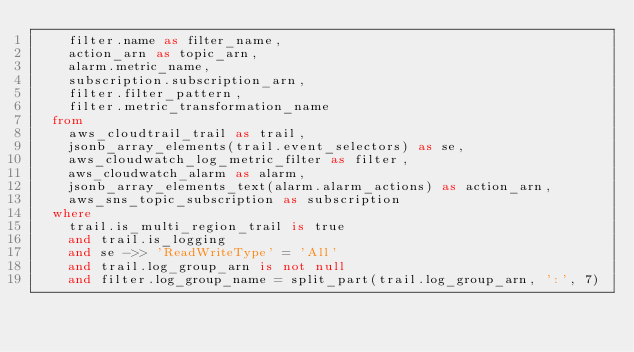<code> <loc_0><loc_0><loc_500><loc_500><_SQL_>    filter.name as filter_name,
    action_arn as topic_arn,
    alarm.metric_name,
    subscription.subscription_arn,
    filter.filter_pattern,
    filter.metric_transformation_name
  from
    aws_cloudtrail_trail as trail,
    jsonb_array_elements(trail.event_selectors) as se,
    aws_cloudwatch_log_metric_filter as filter,
    aws_cloudwatch_alarm as alarm,
    jsonb_array_elements_text(alarm.alarm_actions) as action_arn,
    aws_sns_topic_subscription as subscription
  where
    trail.is_multi_region_trail is true
    and trail.is_logging
    and se ->> 'ReadWriteType' = 'All'
    and trail.log_group_arn is not null
    and filter.log_group_name = split_part(trail.log_group_arn, ':', 7)</code> 